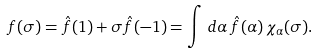<formula> <loc_0><loc_0><loc_500><loc_500>f ( \sigma ) = \hat { f } ( 1 ) + \sigma \hat { f } ( - 1 ) = \int \, d \alpha \, \hat { f } ( \alpha ) \, \chi _ { \alpha } ( \sigma ) .</formula> 